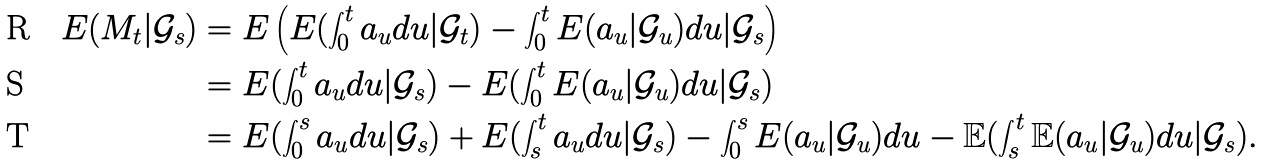Convert formula to latex. <formula><loc_0><loc_0><loc_500><loc_500>E ( M _ { t } | \mathcal { G } _ { s } ) & = E \left ( E ( \int _ { 0 } ^ { t } a _ { u } d u | \mathcal { G } _ { t } ) - \int _ { 0 } ^ { t } E ( a _ { u } | \mathcal { G } _ { u } ) d u | \mathcal { G } _ { s } \right ) \\ & = E ( \int _ { 0 } ^ { t } a _ { u } d u | \mathcal { G } _ { s } ) - E ( \int _ { 0 } ^ { t } E ( a _ { u } | \mathcal { G } _ { u } ) d u | \mathcal { G } _ { s } ) \\ & = E ( \int _ { 0 } ^ { s } a _ { u } d u | \mathcal { G } _ { s } ) + E ( \int _ { s } ^ { t } a _ { u } d u | \mathcal { G } _ { s } ) - \int _ { 0 } ^ { s } E ( a _ { u } | \mathcal { G } _ { u } ) d u - \mathbb { E } ( \int _ { s } ^ { t } \mathbb { E } ( a _ { u } | \mathcal { G } _ { u } ) d u | \mathcal { G } _ { s } ) .</formula> 